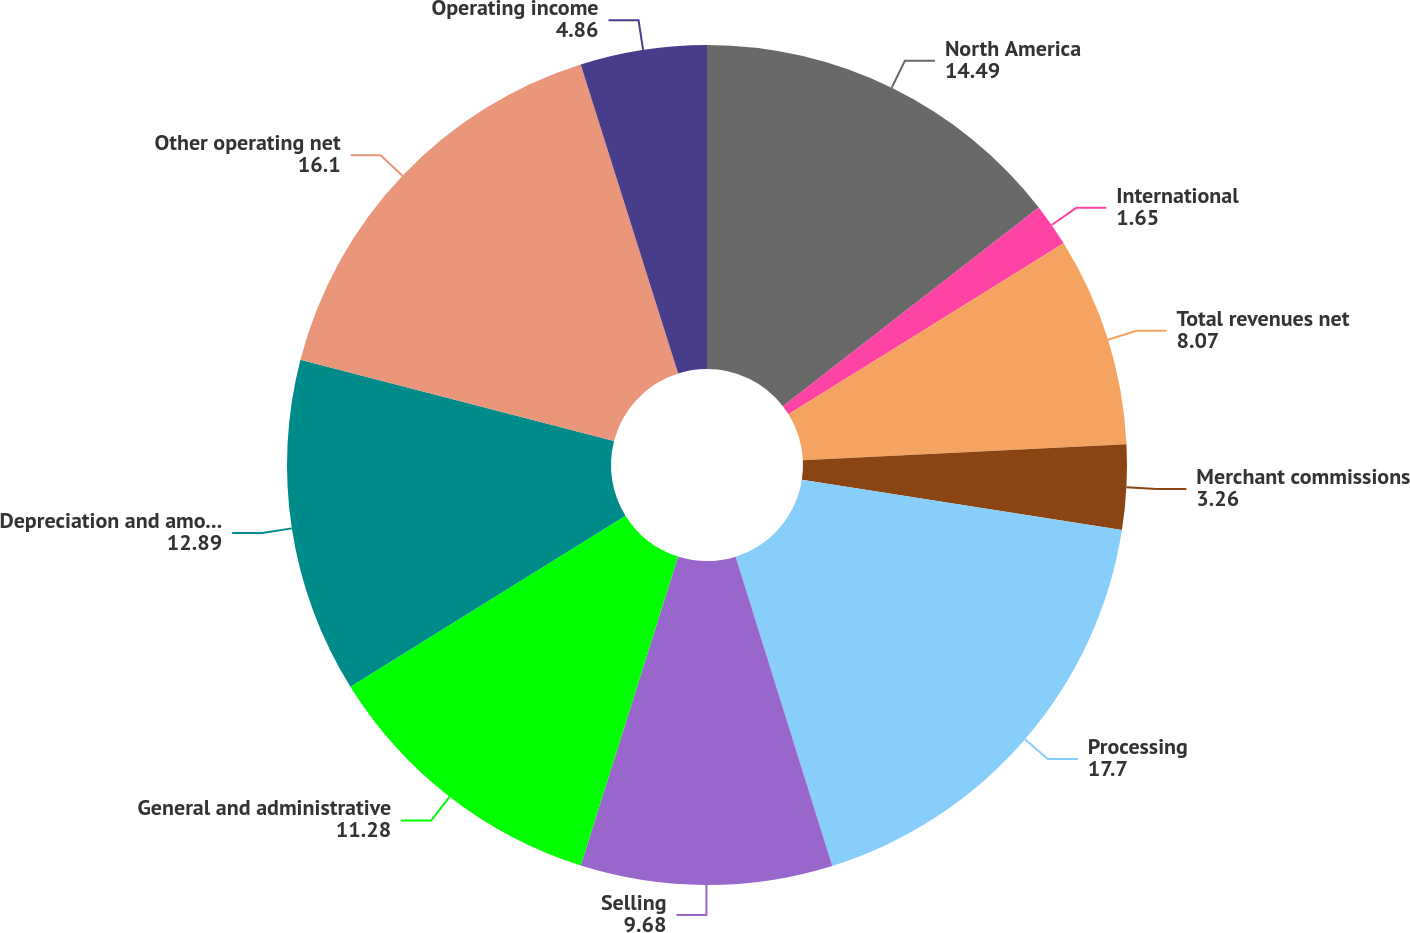Convert chart to OTSL. <chart><loc_0><loc_0><loc_500><loc_500><pie_chart><fcel>North America<fcel>International<fcel>Total revenues net<fcel>Merchant commissions<fcel>Processing<fcel>Selling<fcel>General and administrative<fcel>Depreciation and amortization<fcel>Other operating net<fcel>Operating income<nl><fcel>14.49%<fcel>1.65%<fcel>8.07%<fcel>3.26%<fcel>17.7%<fcel>9.68%<fcel>11.28%<fcel>12.89%<fcel>16.1%<fcel>4.86%<nl></chart> 